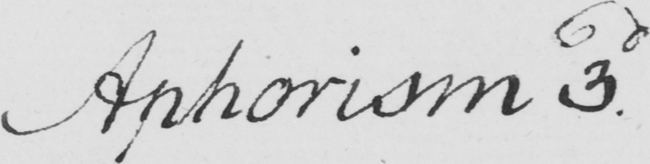What text is written in this handwritten line? Aphorism 3d 